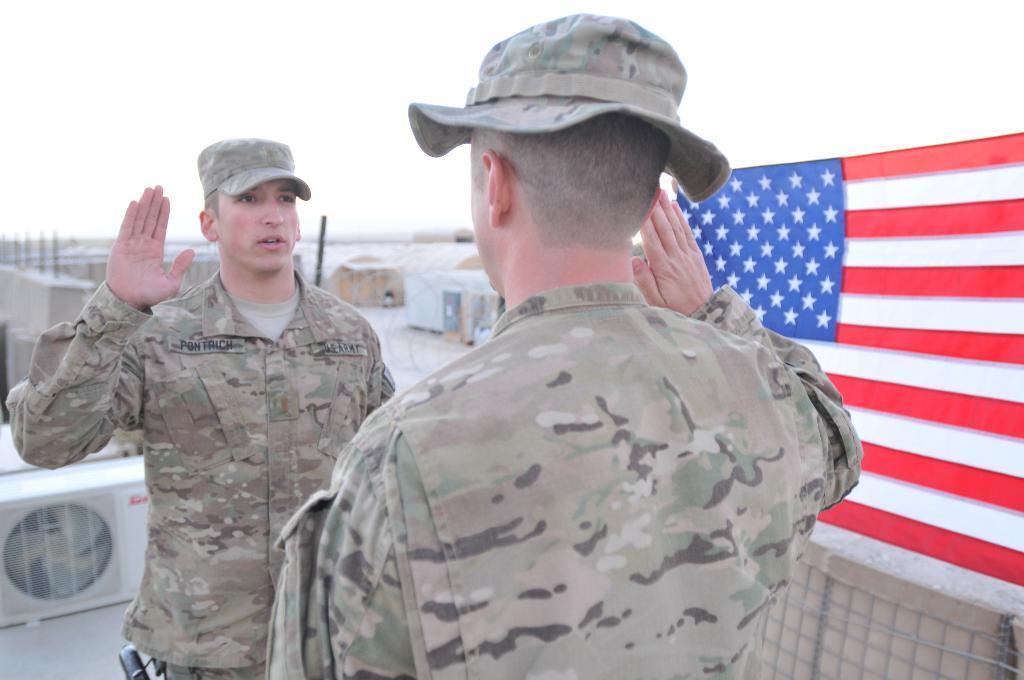Can you describe this image briefly? In this image we can see two persons and they both wearing uniform and we can see a flag on the right side of the image and there is an air conditioner on the left side of the image. At the top we can see the sky. 